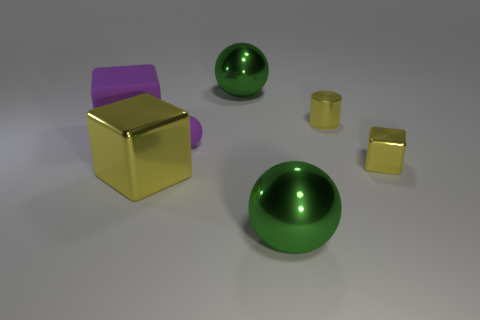Subtract all large shiny blocks. How many blocks are left? 2 Add 1 large cubes. How many objects exist? 8 Subtract all purple cubes. How many cubes are left? 2 Subtract all green cylinders. How many yellow blocks are left? 2 Subtract all spheres. How many objects are left? 4 Subtract 1 balls. How many balls are left? 2 Subtract all purple cylinders. Subtract all red balls. How many cylinders are left? 1 Subtract all tiny purple rubber balls. Subtract all green shiny things. How many objects are left? 4 Add 6 big yellow blocks. How many big yellow blocks are left? 7 Add 2 big red cylinders. How many big red cylinders exist? 2 